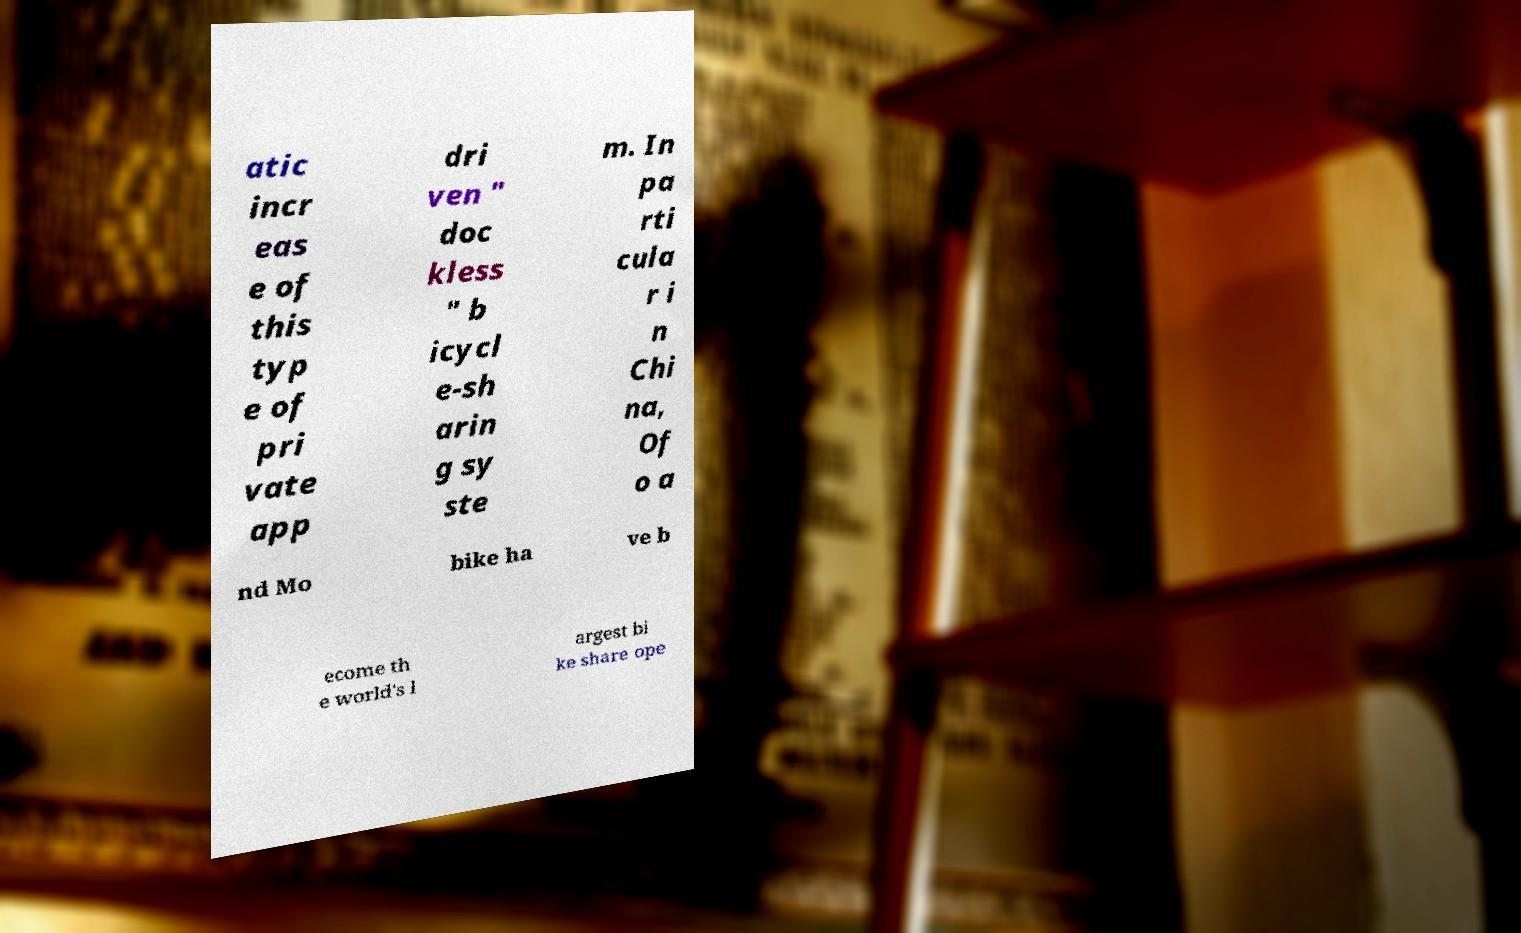What messages or text are displayed in this image? I need them in a readable, typed format. atic incr eas e of this typ e of pri vate app dri ven " doc kless " b icycl e-sh arin g sy ste m. In pa rti cula r i n Chi na, Of o a nd Mo bike ha ve b ecome th e world's l argest bi ke share ope 